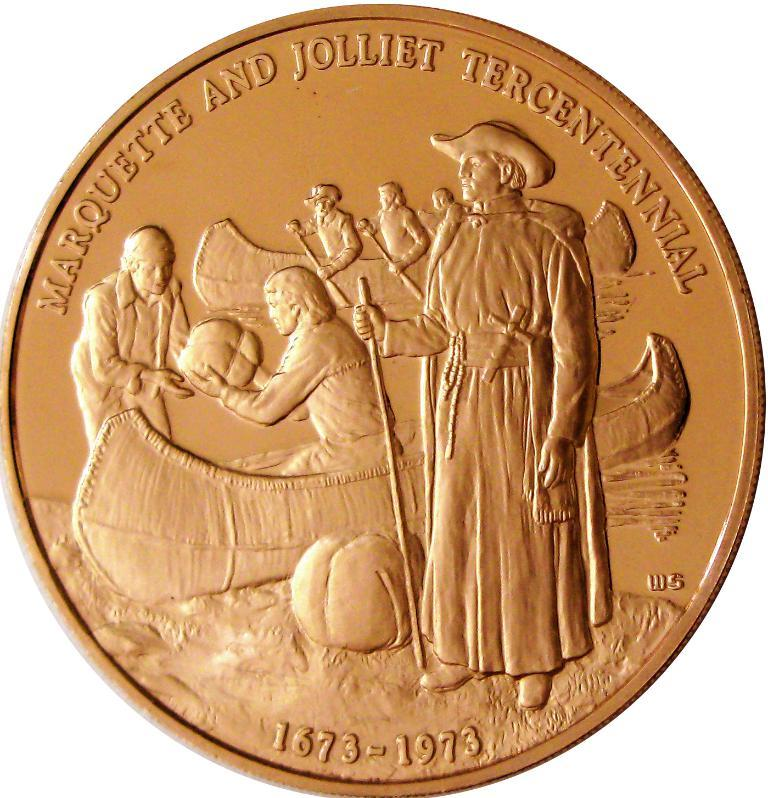Provide a one-sentence caption for the provided image. A coin engraved with Marquette and Jolliet Tercentenniel with the dates 1673-1973. 